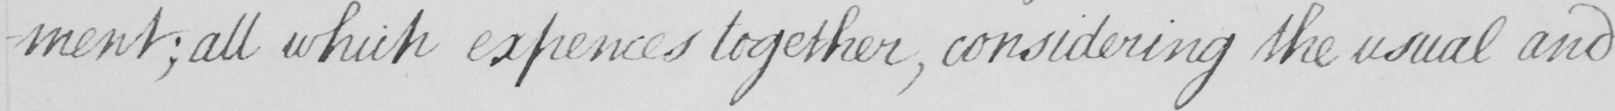What is written in this line of handwriting? -ment  ; all which expences together  , considering the usual and 